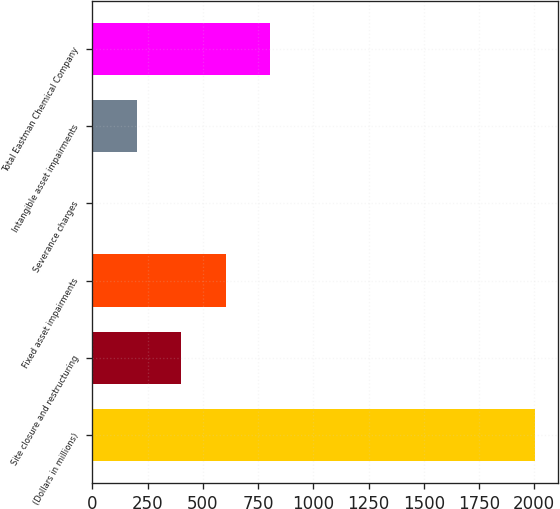<chart> <loc_0><loc_0><loc_500><loc_500><bar_chart><fcel>(Dollars in millions)<fcel>Site closure and restructuring<fcel>Fixed asset impairments<fcel>Severance charges<fcel>Intangible asset impairments<fcel>Total Eastman Chemical Company<nl><fcel>2005<fcel>403.4<fcel>603.6<fcel>3<fcel>203.2<fcel>803.8<nl></chart> 